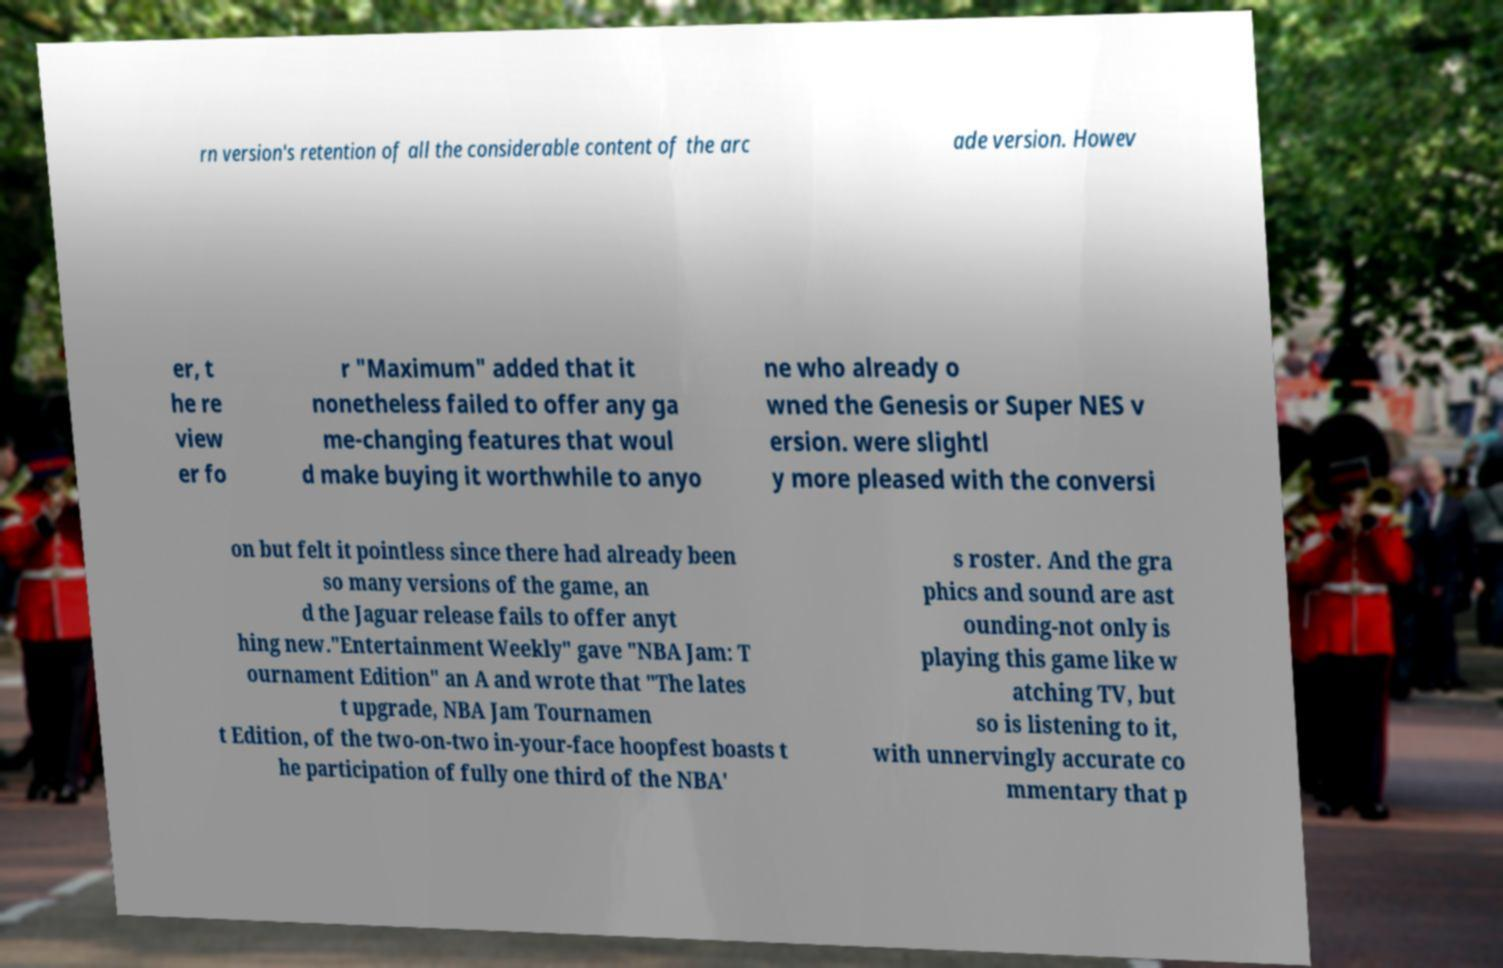For documentation purposes, I need the text within this image transcribed. Could you provide that? rn version's retention of all the considerable content of the arc ade version. Howev er, t he re view er fo r "Maximum" added that it nonetheless failed to offer any ga me-changing features that woul d make buying it worthwhile to anyo ne who already o wned the Genesis or Super NES v ersion. were slightl y more pleased with the conversi on but felt it pointless since there had already been so many versions of the game, an d the Jaguar release fails to offer anyt hing new."Entertainment Weekly" gave "NBA Jam: T ournament Edition" an A and wrote that "The lates t upgrade, NBA Jam Tournamen t Edition, of the two-on-two in-your-face hoopfest boasts t he participation of fully one third of the NBA' s roster. And the gra phics and sound are ast ounding-not only is playing this game like w atching TV, but so is listening to it, with unnervingly accurate co mmentary that p 